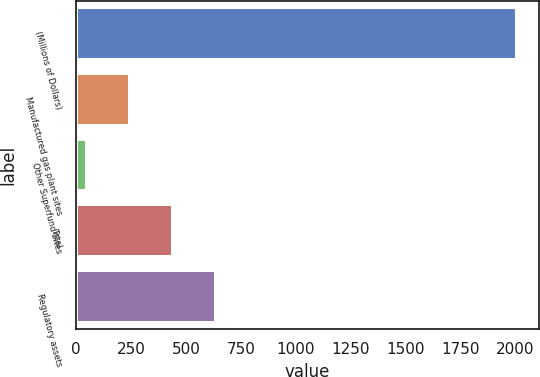Convert chart to OTSL. <chart><loc_0><loc_0><loc_500><loc_500><bar_chart><fcel>(Millions of Dollars)<fcel>Manufactured gas plant sites<fcel>Other Superfund Sites<fcel>Total<fcel>Regulatory assets<nl><fcel>2009<fcel>244.1<fcel>48<fcel>440.2<fcel>636.3<nl></chart> 